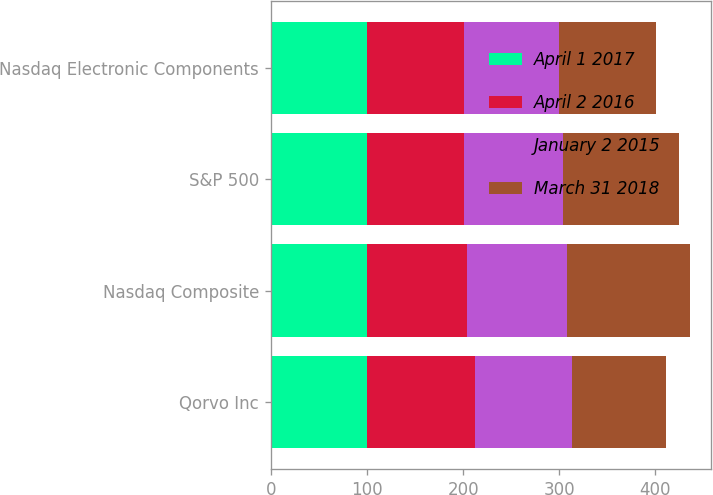Convert chart to OTSL. <chart><loc_0><loc_0><loc_500><loc_500><stacked_bar_chart><ecel><fcel>Qorvo Inc<fcel>Nasdaq Composite<fcel>S&P 500<fcel>Nasdaq Electronic Components<nl><fcel>April 1 2017<fcel>100<fcel>100<fcel>100<fcel>100<nl><fcel>April 2 2016<fcel>112.61<fcel>103.6<fcel>100.95<fcel>100.94<nl><fcel>January 2 2015<fcel>100.945<fcel>104.64<fcel>102.75<fcel>98.56<nl><fcel>March 31 2018<fcel>97.39<fcel>127.64<fcel>120.39<fcel>100.945<nl></chart> 